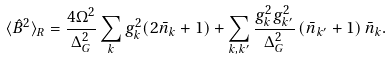<formula> <loc_0><loc_0><loc_500><loc_500>\langle \hat { B } ^ { 2 } \rangle _ { R } = \frac { 4 \Omega ^ { 2 } } { \Delta _ { G } ^ { 2 } } \sum _ { k } g _ { k } ^ { 2 } ( 2 \bar { n } _ { k } + 1 ) + \sum _ { k , k ^ { \prime } } \frac { g _ { k } ^ { 2 } g _ { k ^ { \prime } } ^ { 2 } } { \Delta _ { G } ^ { 2 } } \left ( \bar { n } _ { k ^ { \prime } } + 1 \right ) \bar { n } _ { k } .</formula> 